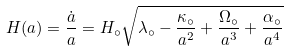Convert formula to latex. <formula><loc_0><loc_0><loc_500><loc_500>H ( a ) = \frac { \dot { a } } { a } = H _ { \circ } \sqrt { \lambda _ { \circ } - \frac { \kappa _ { \circ } } { a ^ { 2 } } + \frac { \Omega _ { \circ } } { a ^ { 3 } } + \frac { \alpha _ { \circ } } { a ^ { 4 } } }</formula> 